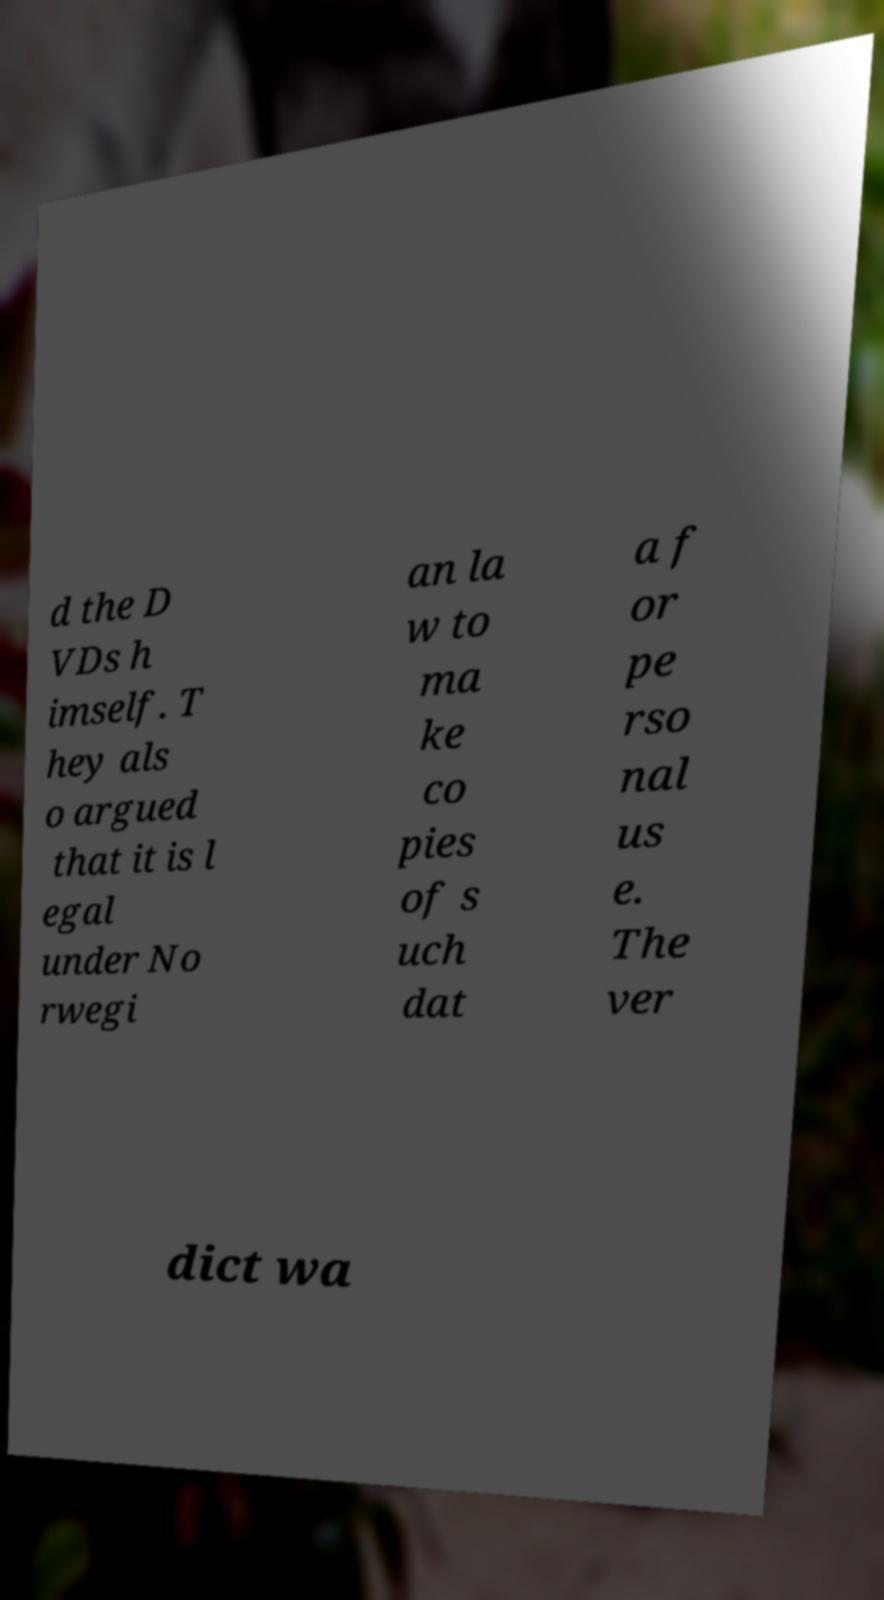There's text embedded in this image that I need extracted. Can you transcribe it verbatim? d the D VDs h imself. T hey als o argued that it is l egal under No rwegi an la w to ma ke co pies of s uch dat a f or pe rso nal us e. The ver dict wa 